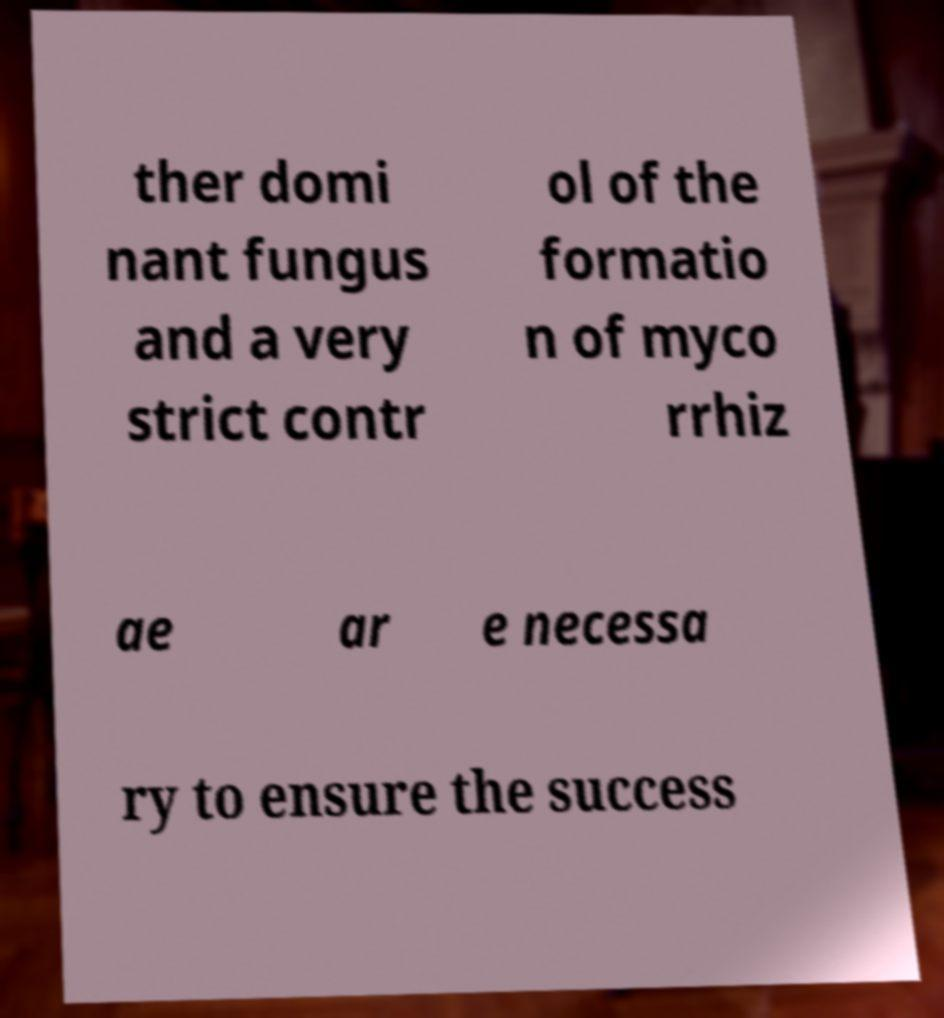Could you assist in decoding the text presented in this image and type it out clearly? ther domi nant fungus and a very strict contr ol of the formatio n of myco rrhiz ae ar e necessa ry to ensure the success 